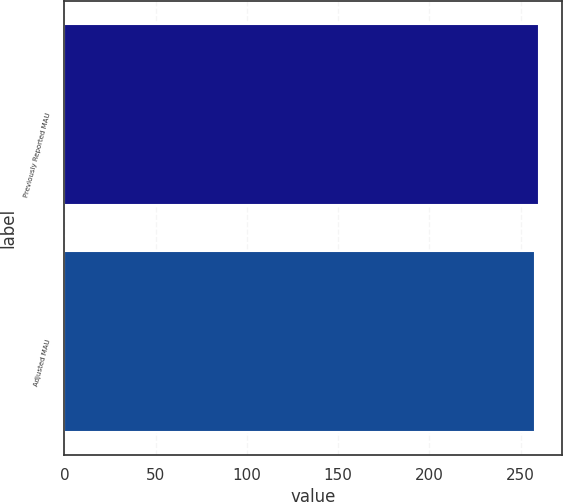Convert chart to OTSL. <chart><loc_0><loc_0><loc_500><loc_500><bar_chart><fcel>Previously Reported MAU<fcel>Adjusted MAU<nl><fcel>260<fcel>258<nl></chart> 